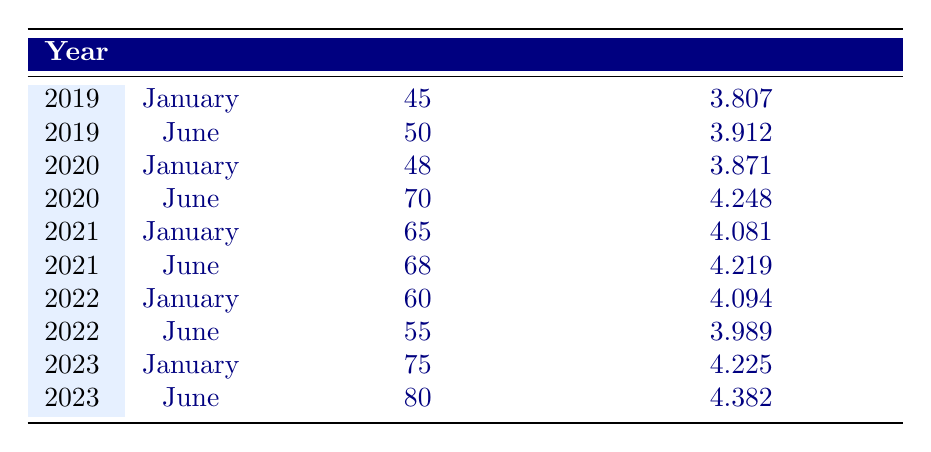What was the occupancy rate in June 2020? The table shows the occupancy rate for June 2020 listed directly as 70%.
Answer: 70% What is the log occupancy rate for January 2021? The table lists the log occupancy rate for January 2021 as 4.081.
Answer: 4.081 What are the average occupancy rates for the years 2022 and 2023? The occupancy rates for 2022 are 60% and 55%, and for 2023 are 75% and 80%. The average for 2022 is (60 + 55)/2 = 57.5%. The average for 2023 is (75 + 80)/2 = 77.5%.
Answer: 57.5% for 2022 and 77.5% for 2023 Is there an increase in the occupancy rate from January 2019 to June 2023? The occupancy rate for January 2019 is 45% and for June 2023 is 80%. Since 80% is higher than 45%, there is indeed an increase.
Answer: Yes What was the highest occupancy rate recorded in the table? The highest occupancy rate in the table is 80% in June 2023.
Answer: 80% What is the difference in log occupancy rates between June 2020 and January 2021? The log occupancy rate for June 2020 is 4.248 and for January 2021 is 4.081. The difference is 4.248 - 4.081 = 0.167.
Answer: 0.167 Did the occupancy rate increase from January 2022 to June 2022? The occupancy rate for January 2022 is 60% and for June 2022 is 55%. Since 55% is less than 60%, there was a decrease.
Answer: No What is the median occupancy rate for all the months reported in the table? The occupancy rates are: 45, 50, 48, 70, 65, 68, 60, 55, 75, 80. When sorted, they are: 45, 48, 50, 55, 60, 65, 68, 70, 75, 80. The median (average of 60 and 65) is (60 + 65)/2 = 62.5.
Answer: 62.5 